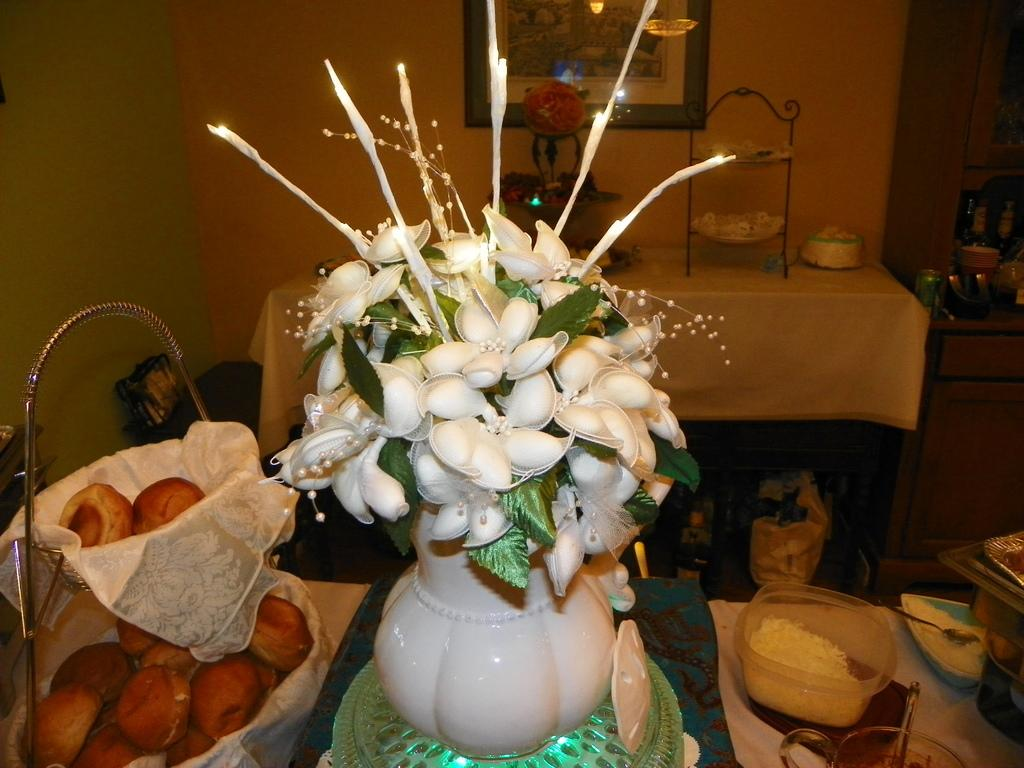What type of container is present in the image for holding flowers? There is a flower vase in the image. What type of containers are present in the image for holding other items? There are baskets and bowls in the image. What type of container is present in the image for holding food items? There is a tin in the image for holding food items. What type of furniture is present in the image? There are tables in the image. What type of illumination is present in the image? There are lights in the image. What type of decoration is present on the wall in the image? There is a frame on the wall in the image. What other unspecified objects are present in the image? There are some unspecified objects in the image. What type of spy equipment can be seen in the image? There is no spy equipment present in the image. What type of station is depicted in the image? There is no station depicted in the image. What type of attempt is being made in the image? There is no attempt being made in the image. 